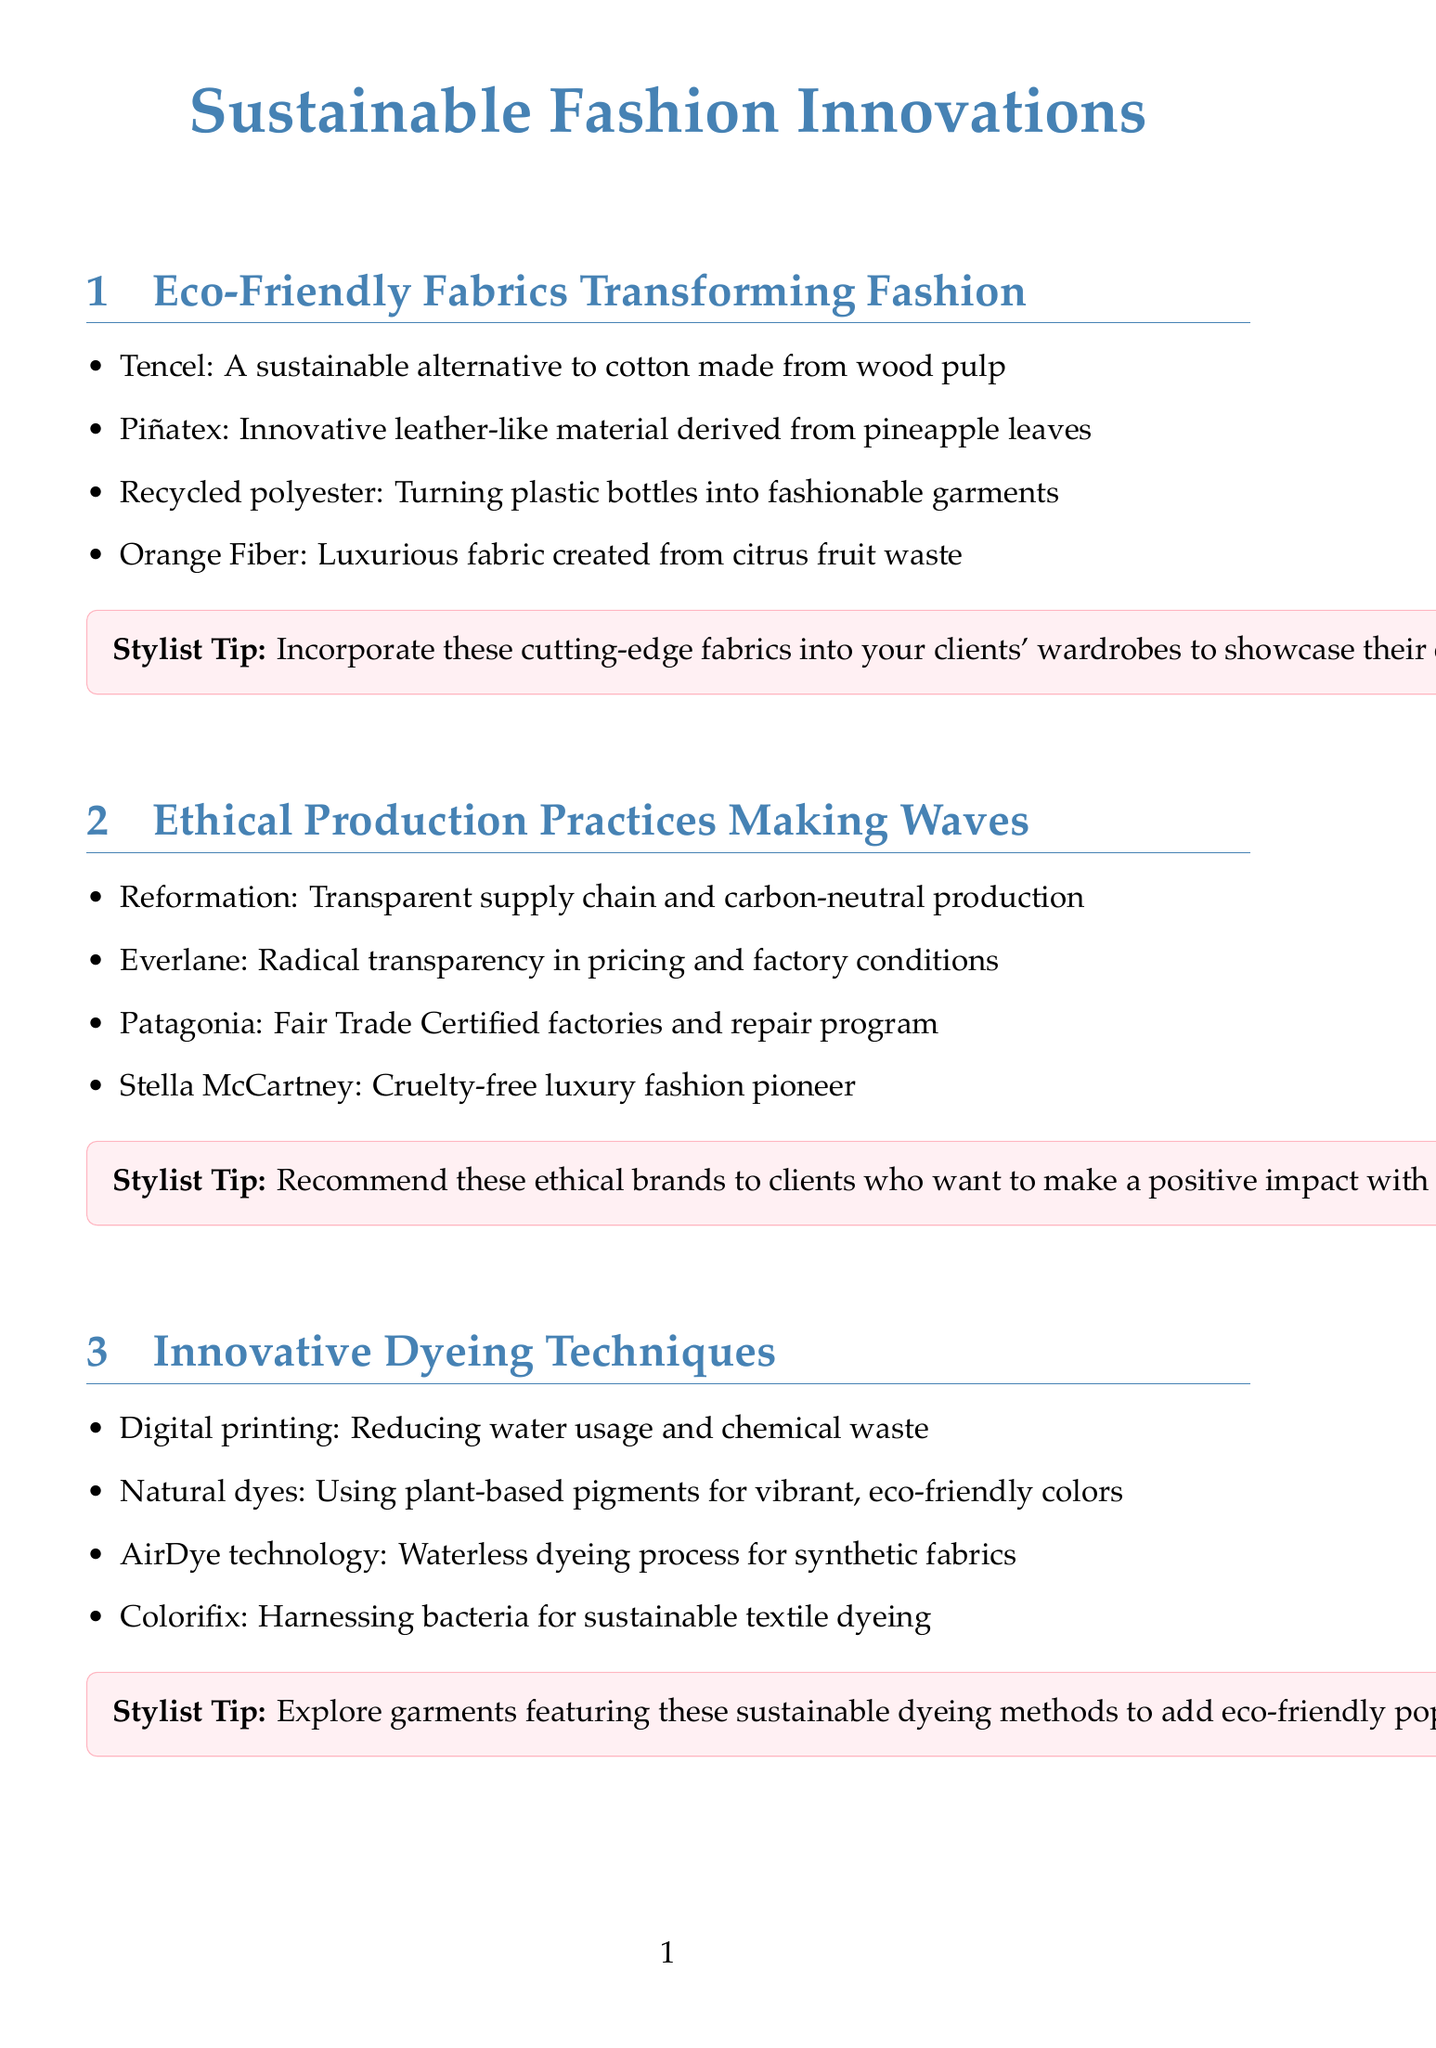What is Tencel made from? Tencel is described as a sustainable alternative to cotton made from wood pulp.
Answer: wood pulp Name one innovative leather-like material mentioned. The document lists Piñatex as an innovative leather-like material derived from pineapple leaves.
Answer: Piñatex Which brand is known for Radical transparency? Everlane is mentioned in the document as the brand known for radical transparency in pricing and factory conditions.
Answer: Everlane When is the Copenhagen Fashion Summit scheduled? The document states that the Copenhagen Fashion Summit is scheduled for May 17-18, 2023.
Answer: May 17-18, 2023 What dyeing technique uses plant-based pigments? The document lists natural dyes as the technique that uses plant-based pigments for vibrant, eco-friendly colors.
Answer: natural dyes Which sustainable brand offers a take-back program? For Days is identified as a brand with a closed-loop clothing system that includes a take-back program.
Answer: For Days What is one of the stylist tips for incorporating eco-friendly fabrics? The stylist tip suggests incorporating cutting-edge fabrics into clients' wardrobes to showcase their eco-conscious style.
Answer: showcase their eco-conscious style Who is a sustainable fashion influencer to follow? The document lists @ecowarriorprincess as one of the sustainable fashion influencers to follow.
Answer: @ecowarriorprincess What is the theme of the newsletter? The newsletter focuses on sustainable fashion innovations, highlighting eco-friendly fabrics and ethical production practices.
Answer: Sustainable Fashion Innovations 